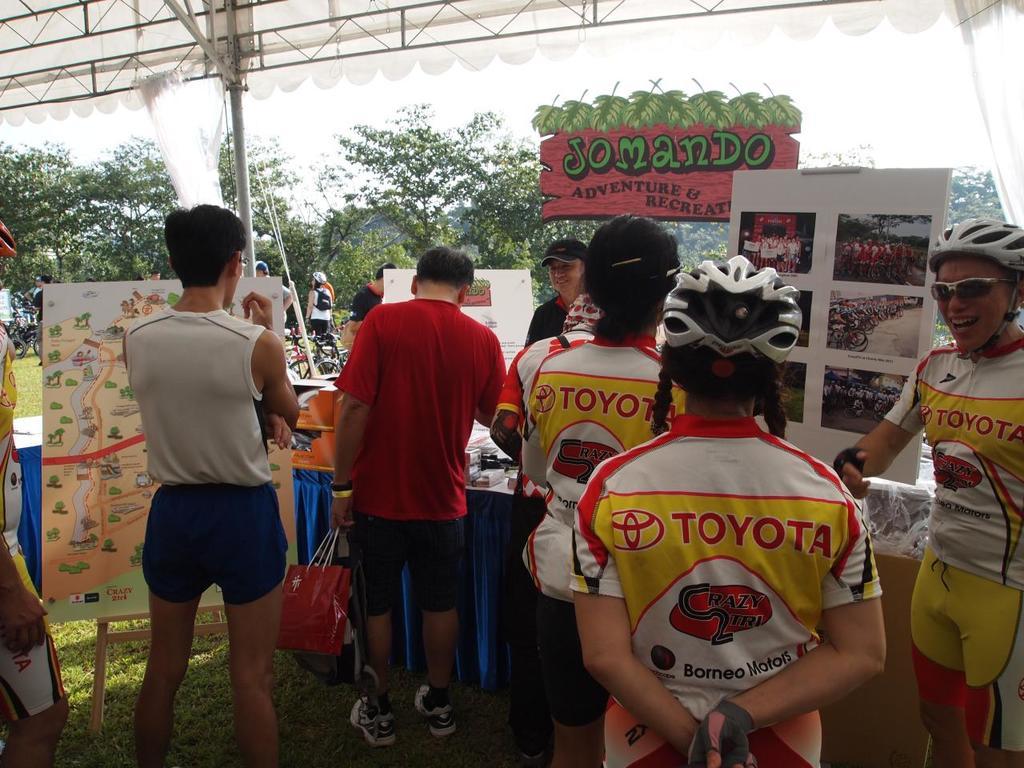What kind of business is being advertised at the table?
Offer a very short reply. Adventure and recreation. What car brand is on the shirts?
Offer a terse response. Toyota. 